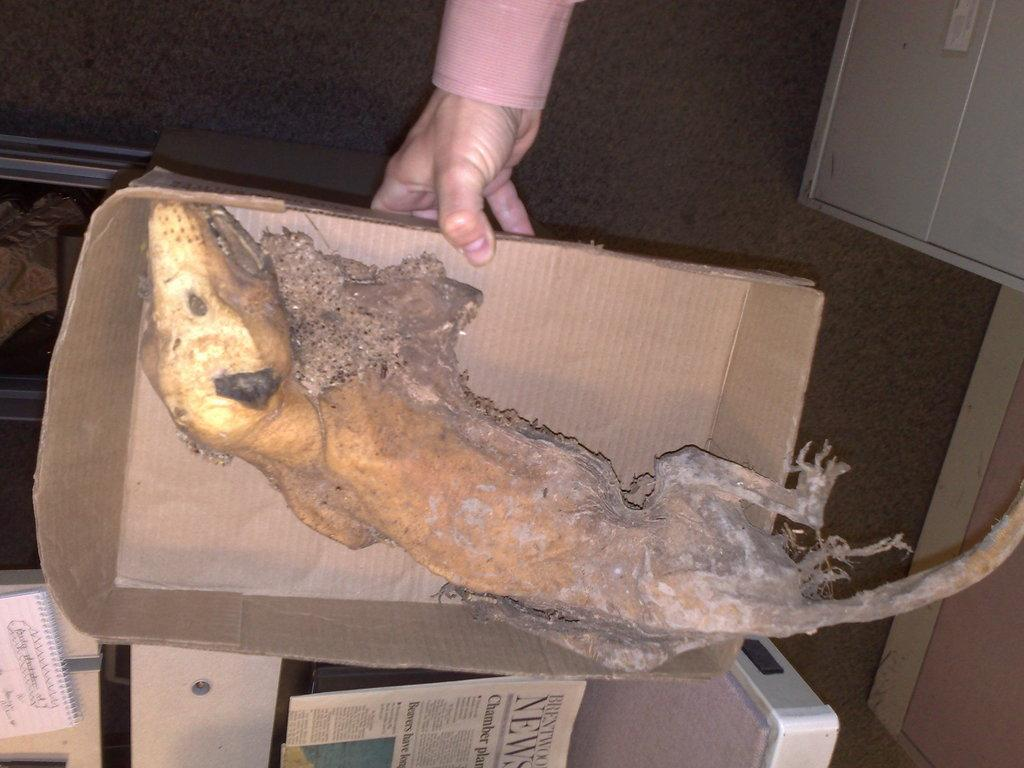What is inside the box in the image? There is an animal in a box in the image. What type of reading material can be seen in the image? There is a newspaper in the image. What type of reading material can be seen besides the newspaper? There is a book in the image. What type of background is visible in the image? There is a wall in the image. What other objects are present in the image? There are objects in the image. Can you describe any body parts visible in the image? There is a person's hand visible in the background of the image. What type of doll is being used as an example in the image? There is no doll present in the image. What type of learning is taking place in the image? There is no indication of learning or any educational activity in the image. 